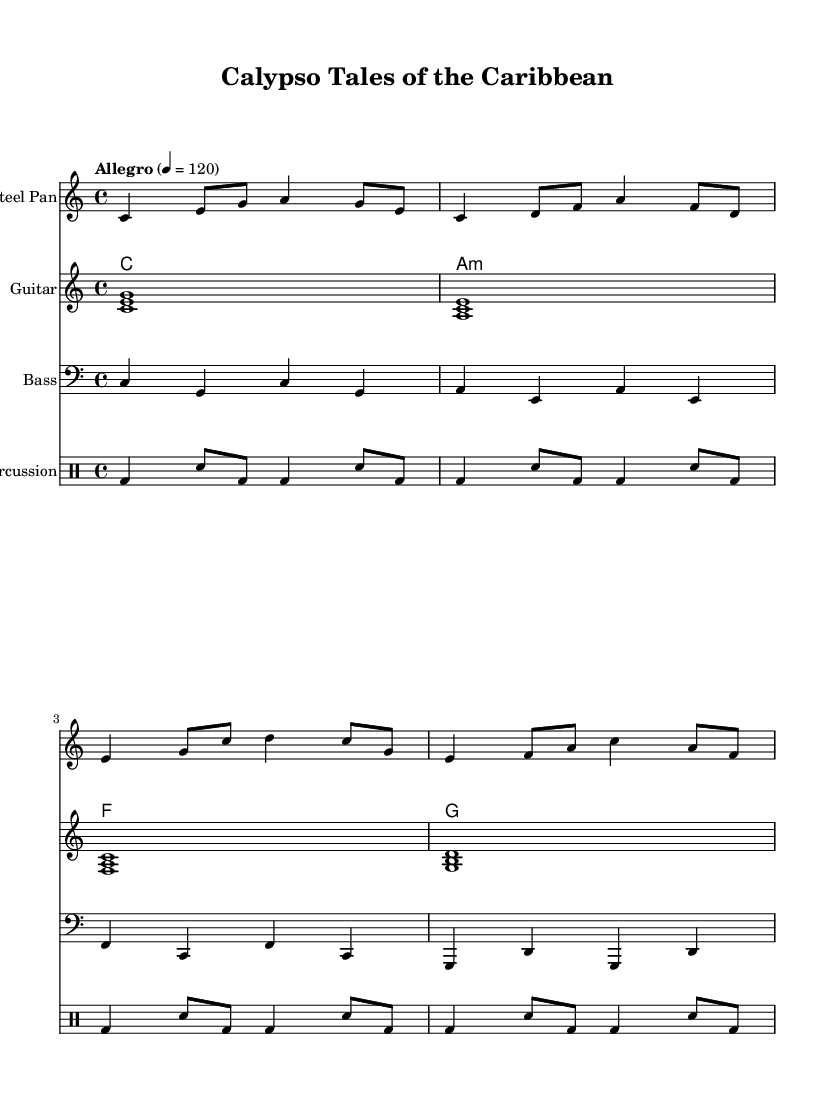What is the key signature of this music? The key signature indicated at the beginning is C major, which has no sharps or flats.
Answer: C major What is the time signature of this music? The time signature is shown at the beginning of the piece as 4/4, meaning there are four beats in each measure and the quarter note gets one beat.
Answer: 4/4 What is the tempo marking for the piece? The tempo marking is indicated as "Allegro" with a metronome marking of 120, suggesting a fast and lively pace of 120 beats per minute.
Answer: Allegro 4 = 120 Which instrument plays the melody in this piece? The melody is primarily played by the steel pan, as noted in the score where it is indicated as the primary melodic instrument.
Answer: Steel Pan How many measures are in the steel pan part? By counting the distinct rhythmic patterns in the steel pan section, there are a total of 8 measures present in that part of the score.
Answer: 8 measures What chords are used in the accompaniment for this piece? The chord symbols above the staff indicate a progression of C major, A minor, F major, and G major, characteristic of Caribbean folk music harmonies.
Answer: C, A minor, F, G What type of rhythm is primarily used in the percussion section? The percussion section primarily uses a mix of bass drum hits and snare drum patterns, creating an engaging calypso rhythm that complements the steel pan melody.
Answer: Calypso rhythm 